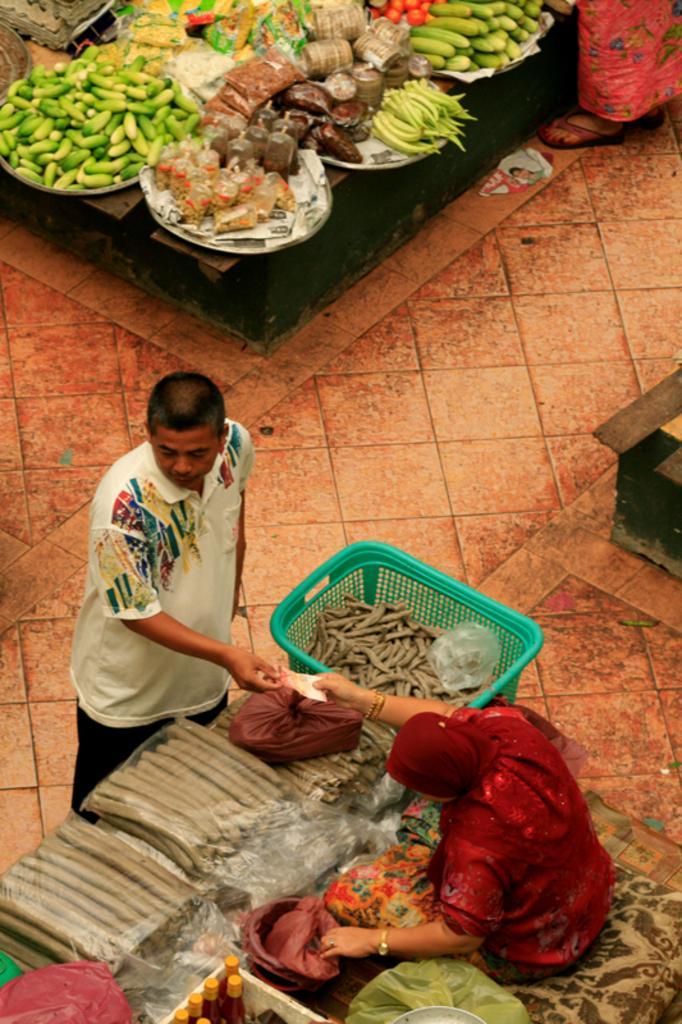Can you describe this image briefly? In this image I can see at the bottom there is a woman, she is giving the money, on the left side a person is standing. It looks like a market, at the top there are vegetables, at the bottom it looks like there are bottles. 